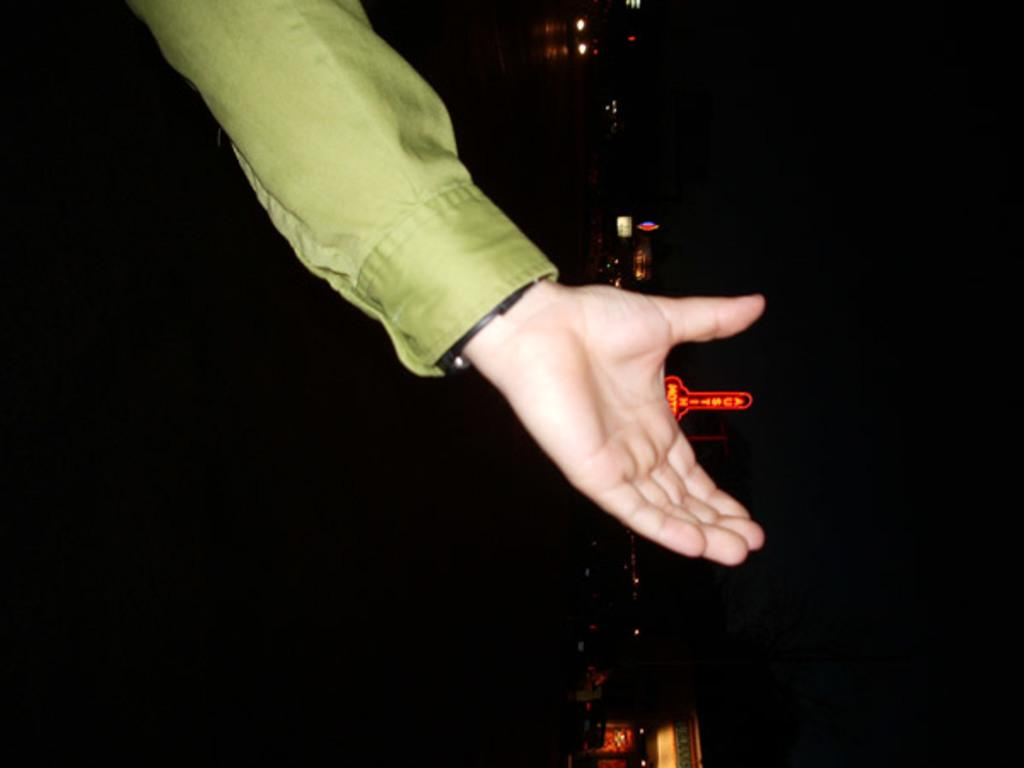What part of a person can be seen in the image? There is a hand of a person in the image. What is the color of the background in the image? The background of the image is dark. What can be seen illuminating the scene in the image? There are lights visible in the image. What type of objects are present in the image? There are boards in the image. What type of prose is being discussed by the tramp in the image? There is no tramp or discussion present in the image; it only features a hand, a dark background, lights, and boards. 